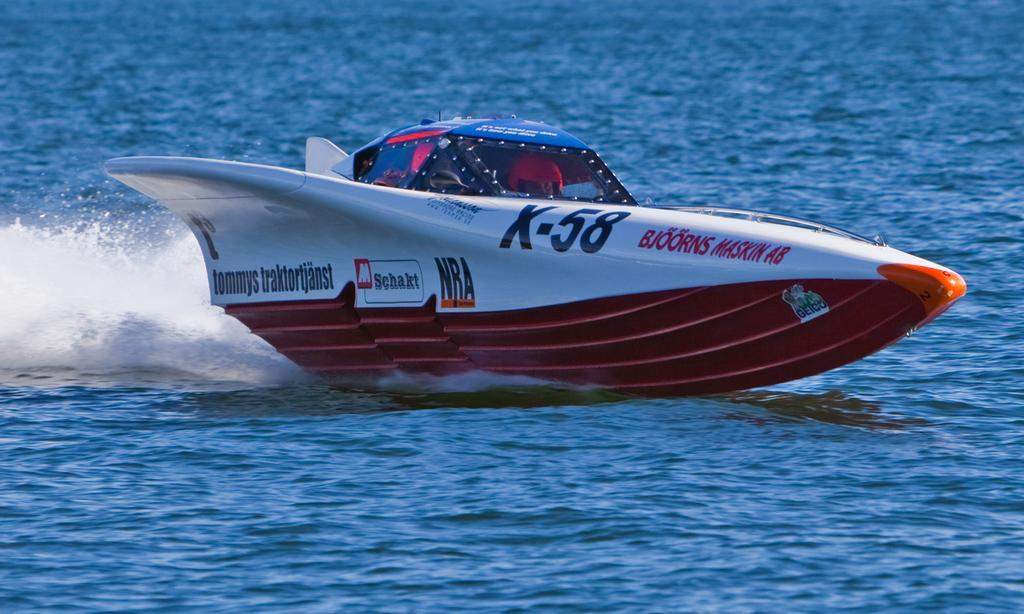Could you give a brief overview of what you see in this image? In this image we can see a boat on the water. 